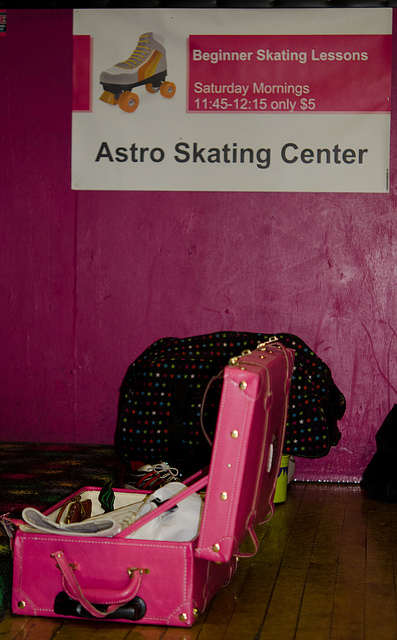Please identify all text content in this image. Beginner Sktaing Astro Skating Center $5 only 15 12 45 11 Mornings Saturday Lessons 